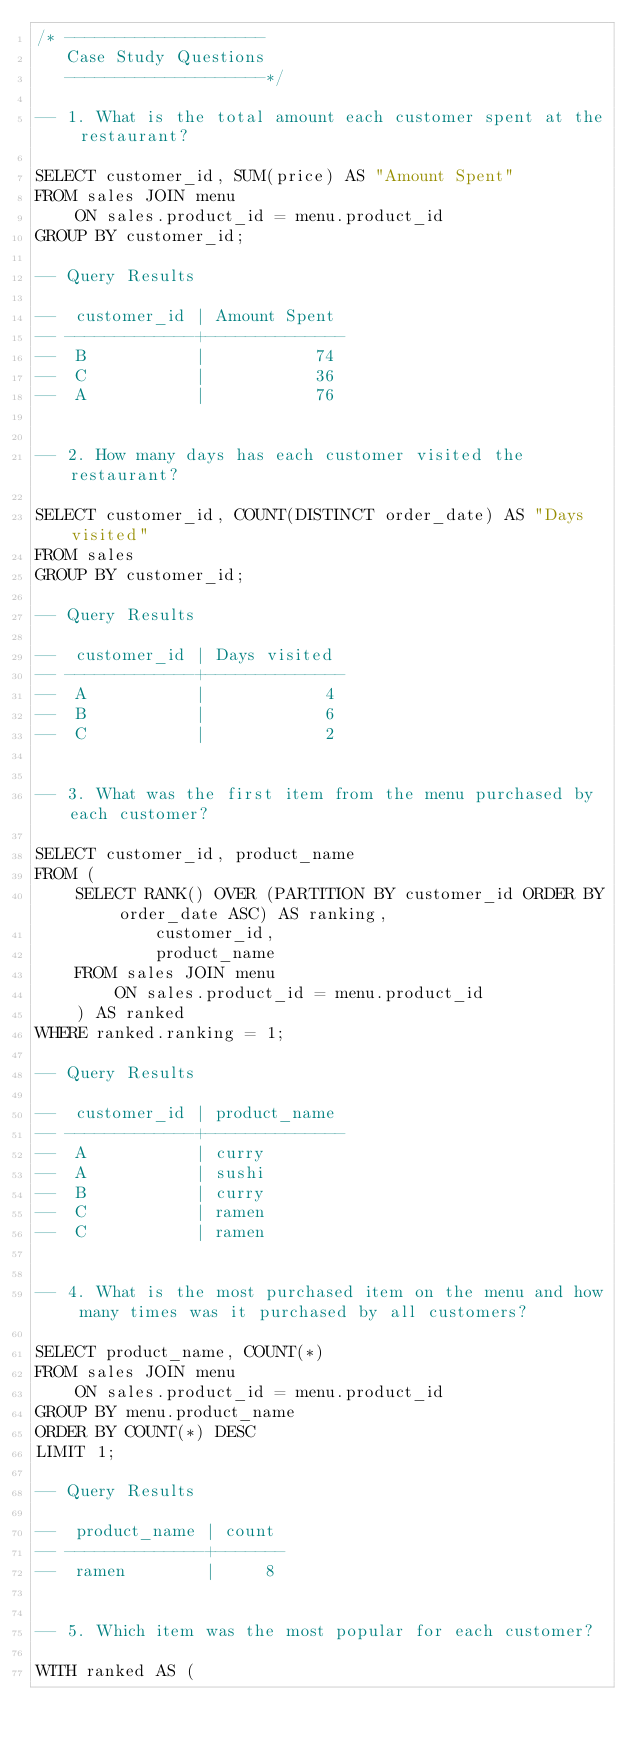Convert code to text. <code><loc_0><loc_0><loc_500><loc_500><_SQL_>/* --------------------
   Case Study Questions
   --------------------*/

-- 1. What is the total amount each customer spent at the restaurant?

SELECT customer_id, SUM(price) AS "Amount Spent"
FROM sales JOIN menu
    ON sales.product_id = menu.product_id
GROUP BY customer_id;

-- Query Results

--  customer_id | Amount Spent 
-- -------------+--------------
--  B           |           74
--  C           |           36
--  A           |           76


-- 2. How many days has each customer visited the restaurant?

SELECT customer_id, COUNT(DISTINCT order_date) AS "Days visited"
FROM sales
GROUP BY customer_id;

-- Query Results

--  customer_id | Days visited 
-- -------------+--------------
--  A           |            4
--  B           |            6
--  C           |            2


-- 3. What was the first item from the menu purchased by each customer?

SELECT customer_id, product_name
FROM (
    SELECT RANK() OVER (PARTITION BY customer_id ORDER BY order_date ASC) AS ranking,
            customer_id,
            product_name
    FROM sales JOIN menu
        ON sales.product_id = menu.product_id
    ) AS ranked
WHERE ranked.ranking = 1;

-- Query Results

--  customer_id | product_name 
-- -------------+--------------
--  A           | curry
--  A           | sushi
--  B           | curry
--  C           | ramen
--  C           | ramen


-- 4. What is the most purchased item on the menu and how many times was it purchased by all customers?

SELECT product_name, COUNT(*)
FROM sales JOIN menu
    ON sales.product_id = menu.product_id
GROUP BY menu.product_name
ORDER BY COUNT(*) DESC
LIMIT 1;

-- Query Results

--  product_name | count 
-- --------------+-------
--  ramen        |     8


-- 5. Which item was the most popular for each customer?

WITH ranked AS (</code> 